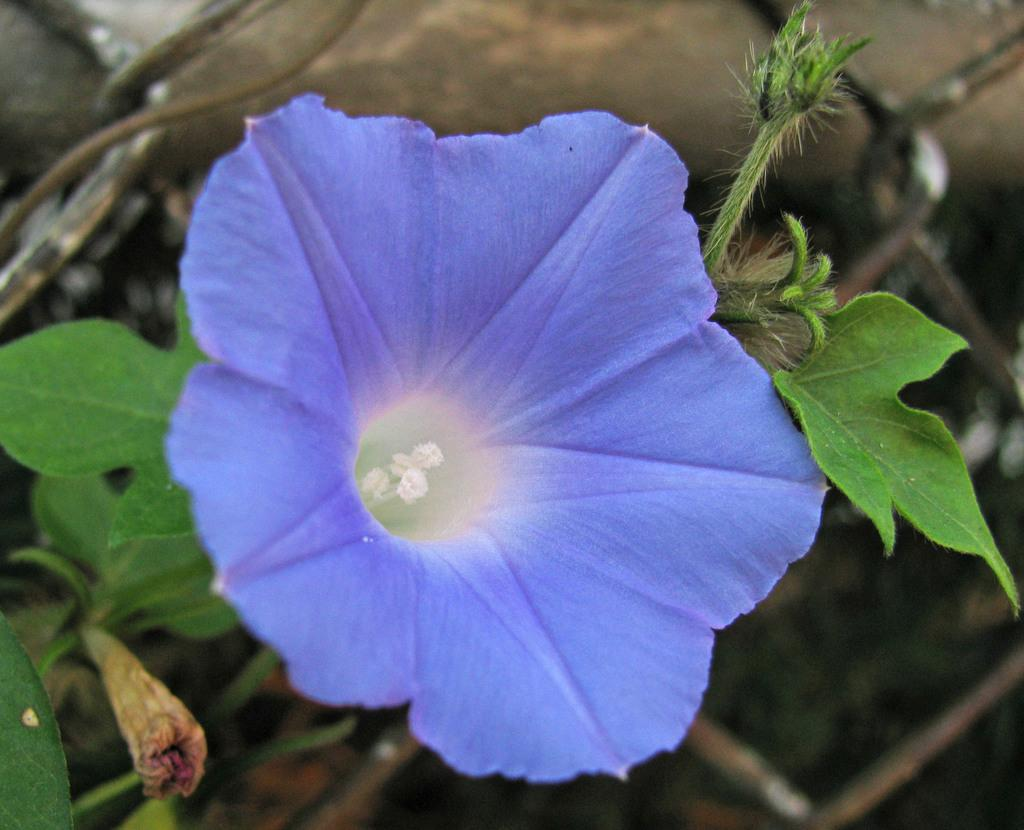What is present in the image? There is a plant in the image. What feature of the plant is mentioned? The plant has a flower. What type of news can be seen on the lake in the image? There is no lake or news present in the image; it only features a plant with a flower. 